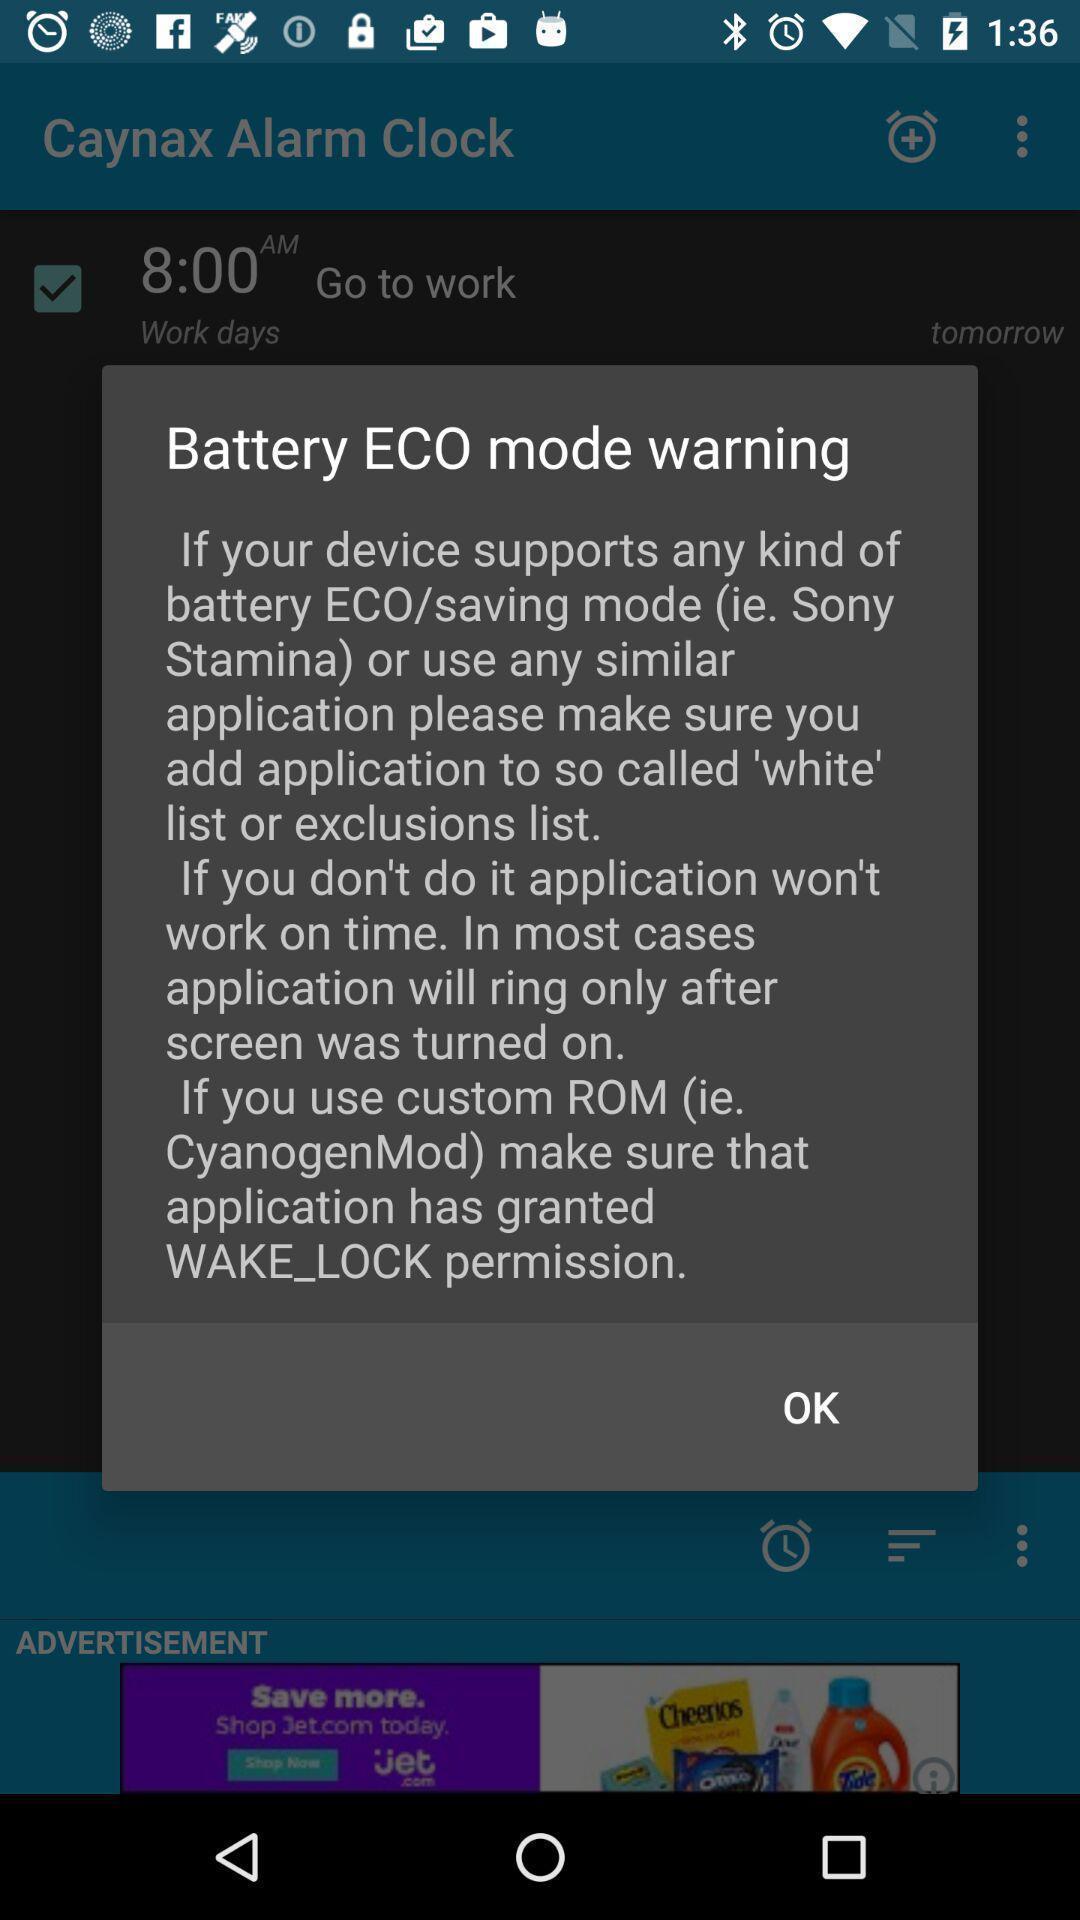Summarize the main components in this picture. Pop-up shows warning text message. 